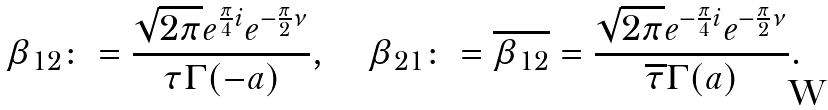<formula> <loc_0><loc_0><loc_500><loc_500>\beta _ { 1 2 } \colon = \frac { \sqrt { 2 \pi } e ^ { \frac { \pi } { 4 } i } e ^ { - \frac { \pi } 2 \nu } } { \tau \Gamma ( - a ) } , \quad \beta _ { 2 1 } \colon = \overline { \beta _ { 1 2 } } = \frac { \sqrt { 2 \pi } e ^ { - \frac { \pi } { 4 } i } e ^ { - \frac { \pi } 2 \nu } } { \overline { \tau } \Gamma ( a ) } .</formula> 